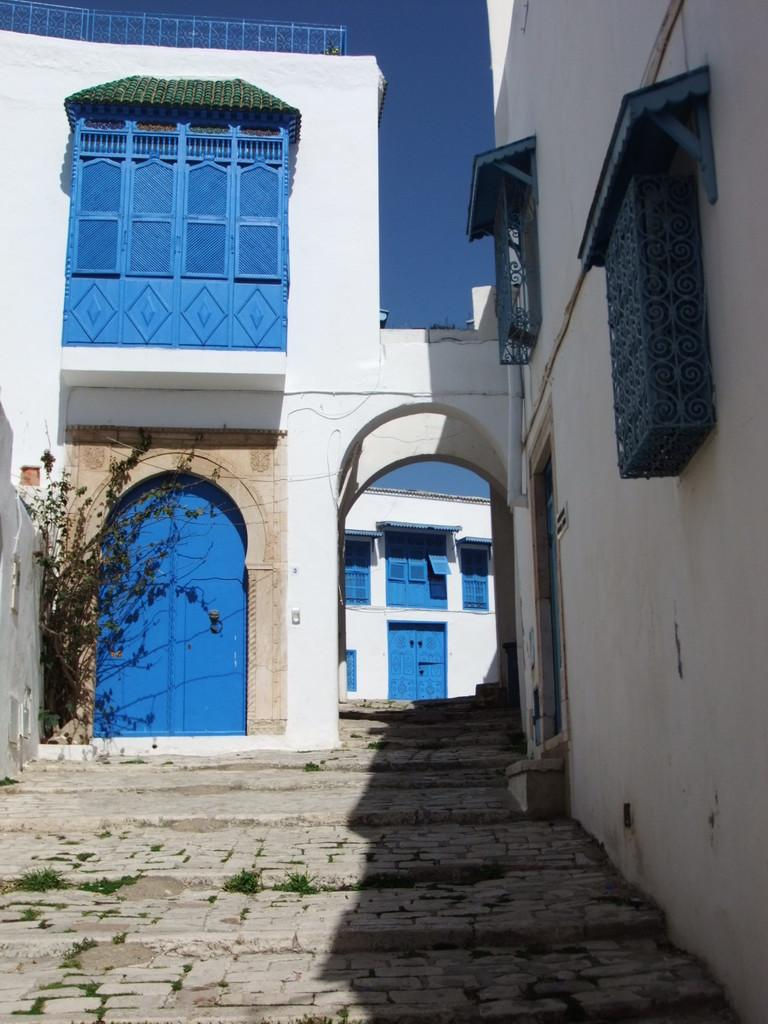What type of structures are present in the image? There are houses in the image. What features do the houses have? The houses have doors and windows. What other object can be seen in the image? There is a tree in the image. What is visible in the background of the image? The sky is visible in the background of the image. What type of ink is being used to write on the cakes in the image? There are no cakes present in the image, so there is no ink being used to write on them. 